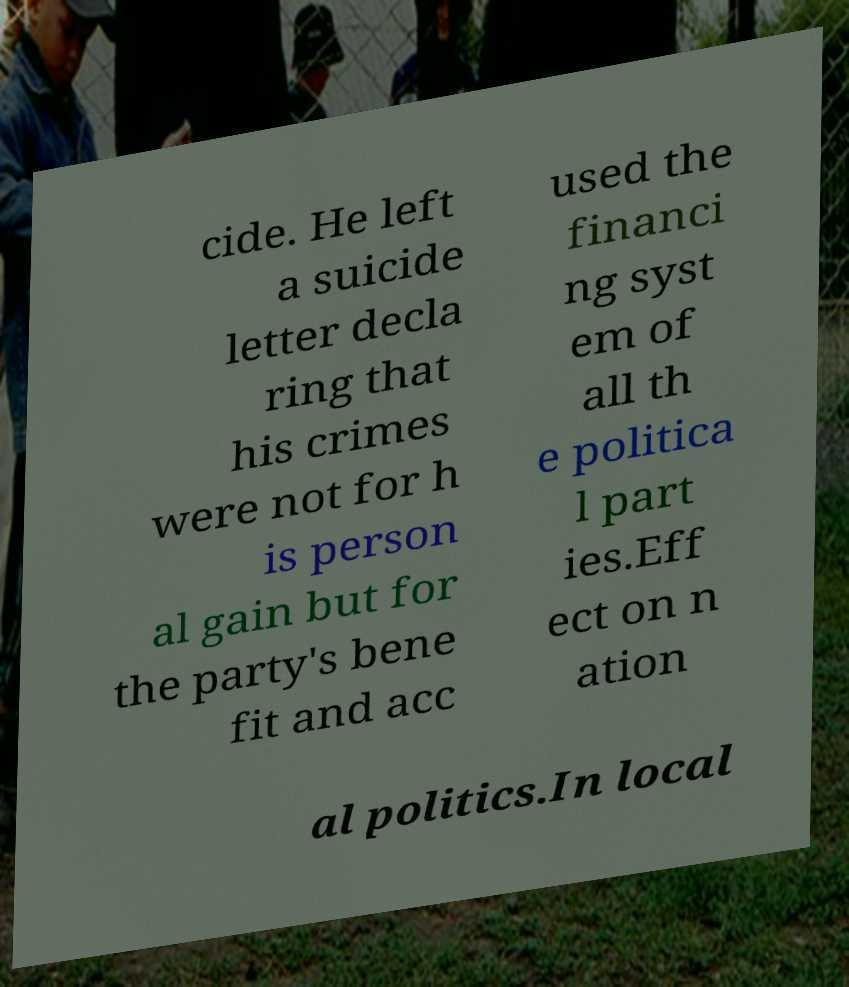I need the written content from this picture converted into text. Can you do that? cide. He left a suicide letter decla ring that his crimes were not for h is person al gain but for the party's bene fit and acc used the financi ng syst em of all th e politica l part ies.Eff ect on n ation al politics.In local 